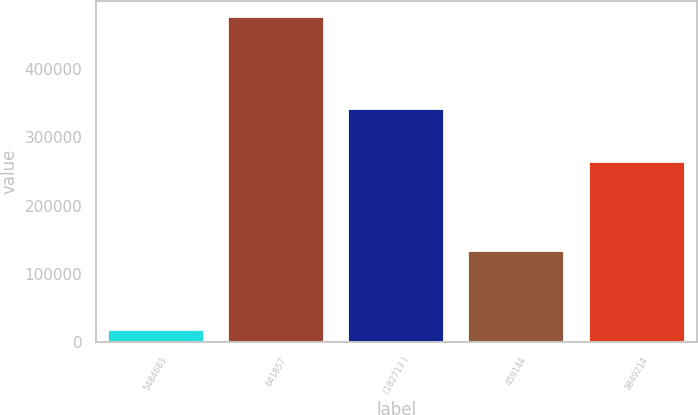<chart> <loc_0><loc_0><loc_500><loc_500><bar_chart><fcel>5484683<fcel>641857<fcel>(182713 )<fcel>459144<fcel>3849214<nl><fcel>18463<fcel>475822<fcel>341448<fcel>134374<fcel>263796<nl></chart> 